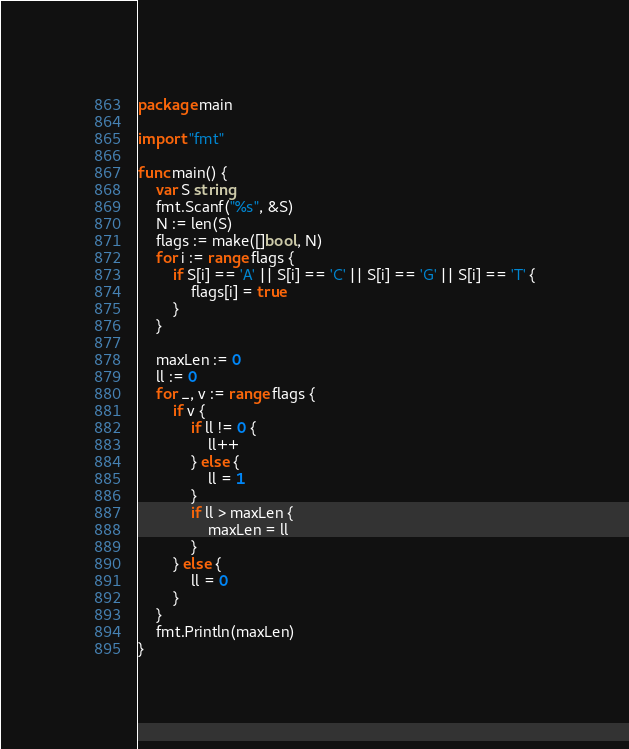Convert code to text. <code><loc_0><loc_0><loc_500><loc_500><_Go_>package main

import "fmt"

func main() {
	var S string
	fmt.Scanf("%s", &S)
	N := len(S)
	flags := make([]bool, N)
	for i := range flags {
		if S[i] == 'A' || S[i] == 'C' || S[i] == 'G' || S[i] == 'T' {
			flags[i] = true
		}
	}

	maxLen := 0
	ll := 0
	for _, v := range flags {
		if v {
			if ll != 0 {
				ll++
			} else {
				ll = 1
			}
			if ll > maxLen {
				maxLen = ll
			}
		} else {
			ll = 0
		}
	}
	fmt.Println(maxLen)
}
</code> 